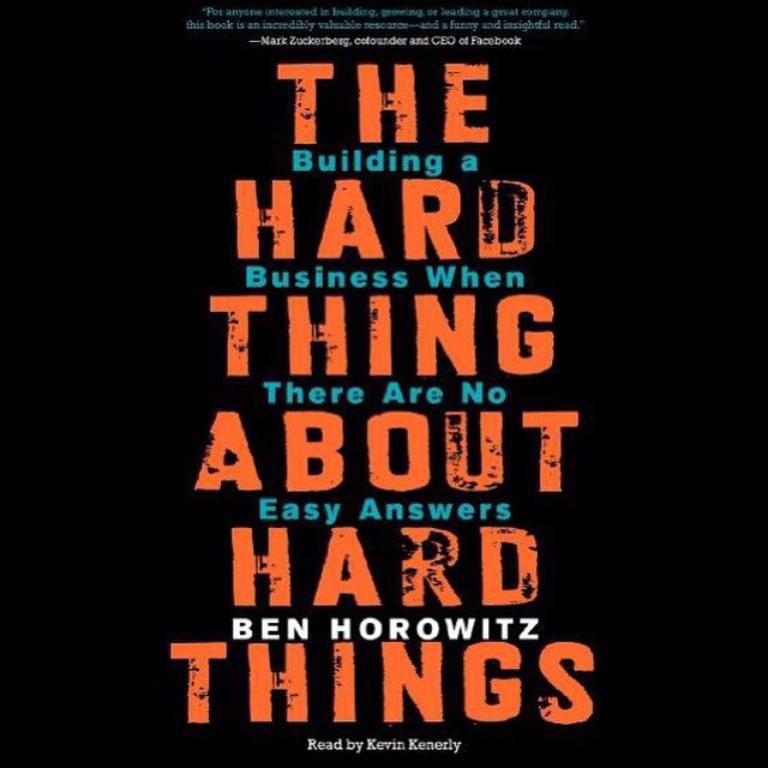<image>
Summarize the visual content of the image. A book cover that is entitled: The building a Hard Business when thing there are no about easy answers hard things. 